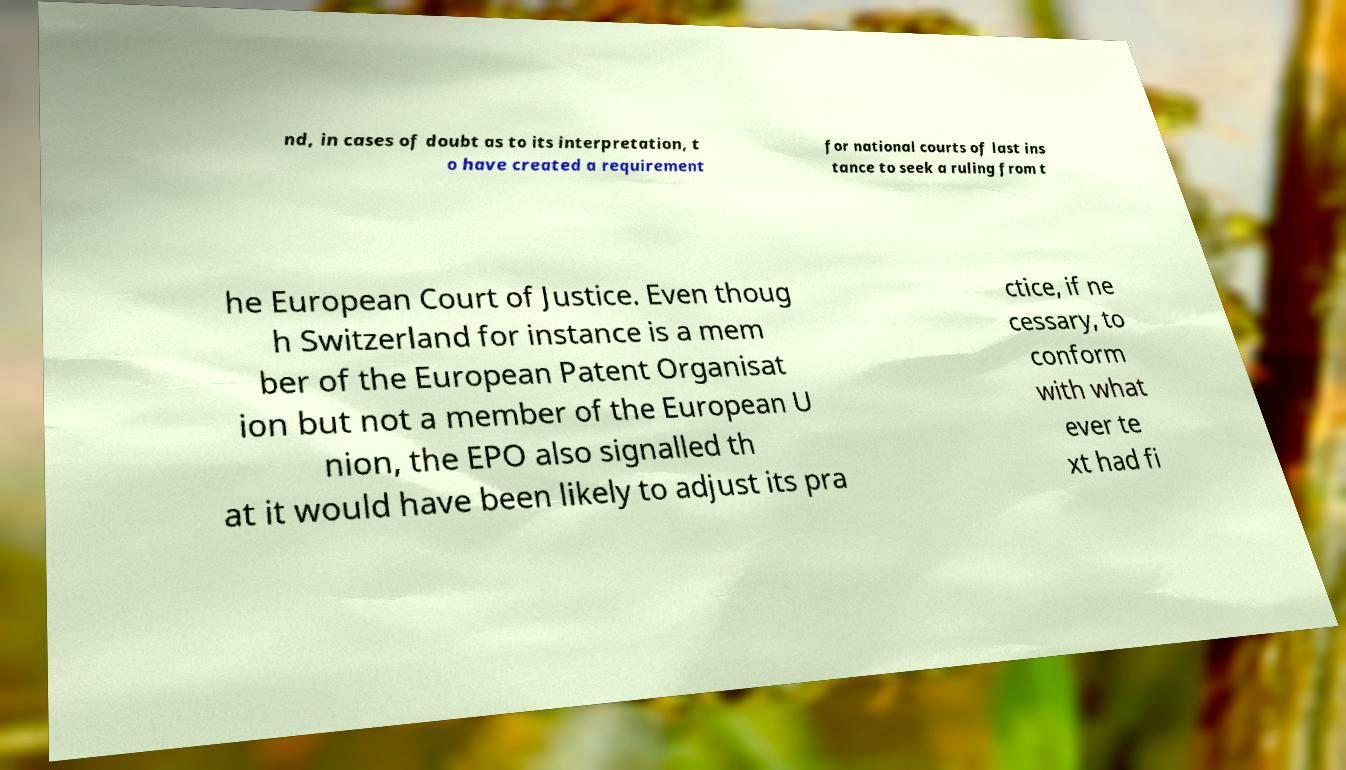For documentation purposes, I need the text within this image transcribed. Could you provide that? nd, in cases of doubt as to its interpretation, t o have created a requirement for national courts of last ins tance to seek a ruling from t he European Court of Justice. Even thoug h Switzerland for instance is a mem ber of the European Patent Organisat ion but not a member of the European U nion, the EPO also signalled th at it would have been likely to adjust its pra ctice, if ne cessary, to conform with what ever te xt had fi 